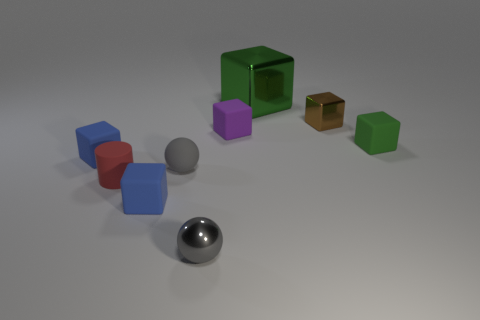There is a small rubber object that is on the right side of the small brown object; is it the same color as the large cube?
Make the answer very short. Yes. Are there more metallic balls behind the small green rubber cube than small rubber blocks that are behind the small purple cube?
Provide a short and direct response. No. How many other objects are the same size as the gray matte sphere?
Keep it short and to the point. 7. What size is the other sphere that is the same color as the tiny shiny ball?
Keep it short and to the point. Small. What is the green object that is left of the green block that is in front of the large green metal block made of?
Provide a short and direct response. Metal. There is a matte sphere; are there any big green shiny blocks right of it?
Your answer should be very brief. Yes. Are there more big green metallic cubes that are behind the big cube than tiny red matte things?
Your answer should be very brief. No. Are there any small rubber cylinders that have the same color as the shiny ball?
Give a very brief answer. No. There is a matte ball that is the same size as the cylinder; what is its color?
Provide a short and direct response. Gray. There is a matte cube that is right of the big green metal object; are there any small green rubber blocks on the left side of it?
Offer a very short reply. No. 